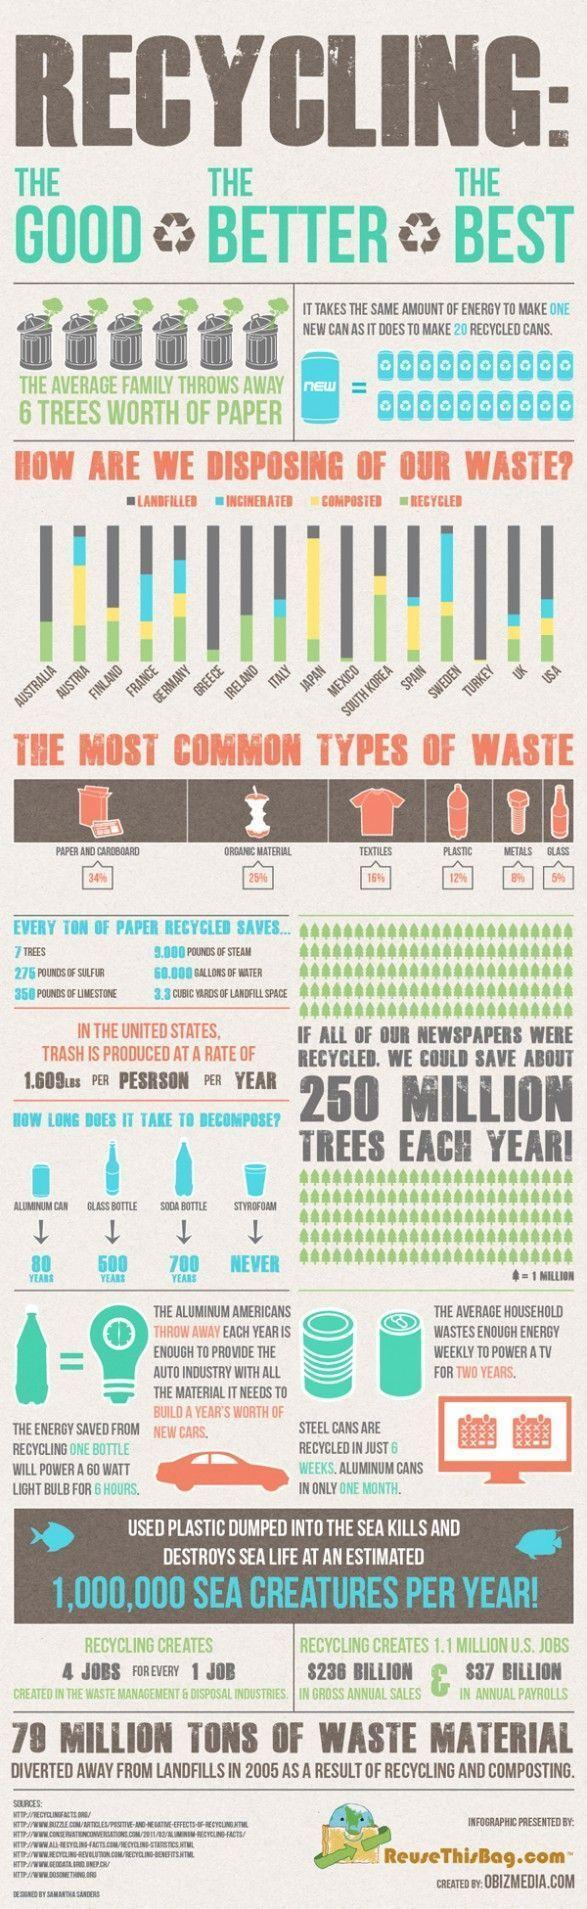How is Australia disposing of their waste?
Answer the question with a short phrase. Landfilled, Recycled What is the percentage of textiles and metal waste, taken together? 24% What is the percentage of plastic and metal waste, taken together? 20% How many years soda bottle take to decompose? 700 How many years glass bottle take to decompose? 500 How is Japan disposing of their waste? Recycled, Composted, Landfilled 